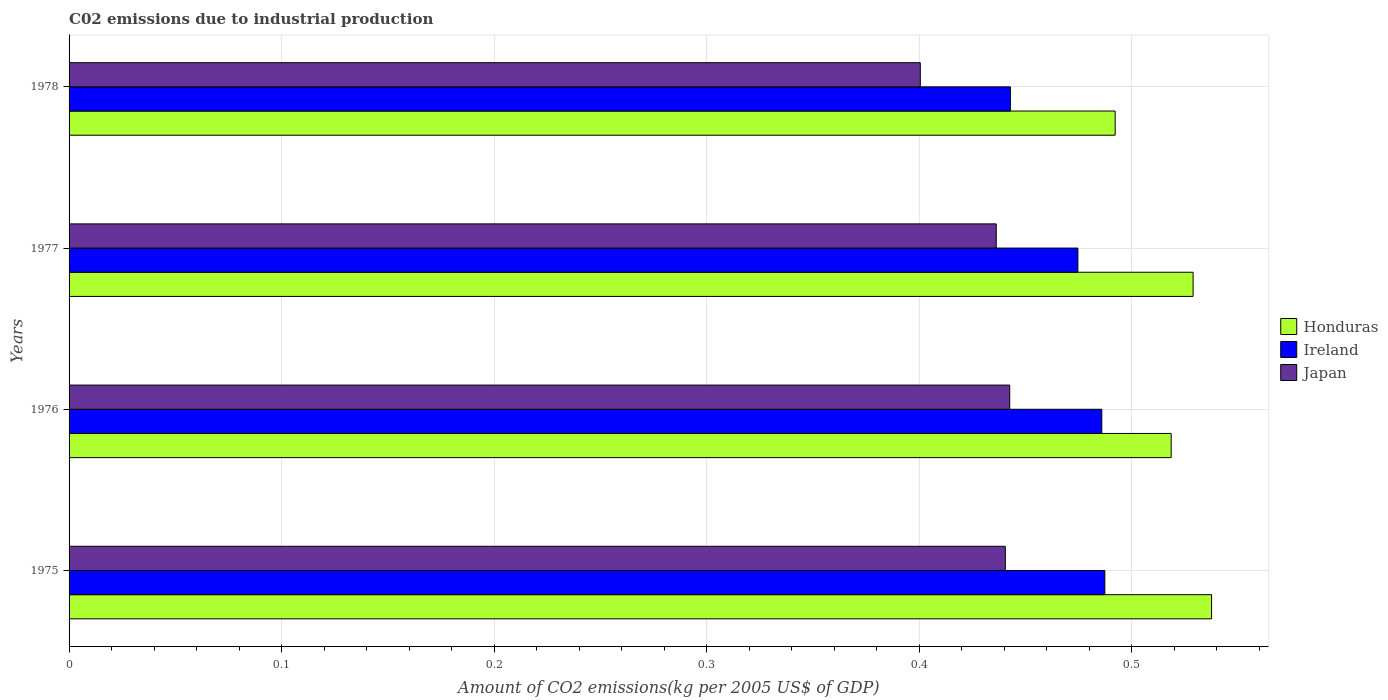Are the number of bars per tick equal to the number of legend labels?
Provide a short and direct response. Yes. How many bars are there on the 2nd tick from the bottom?
Offer a terse response. 3. What is the label of the 1st group of bars from the top?
Keep it short and to the point. 1978. What is the amount of CO2 emitted due to industrial production in Ireland in 1975?
Provide a short and direct response. 0.49. Across all years, what is the maximum amount of CO2 emitted due to industrial production in Japan?
Provide a succinct answer. 0.44. Across all years, what is the minimum amount of CO2 emitted due to industrial production in Japan?
Provide a succinct answer. 0.4. In which year was the amount of CO2 emitted due to industrial production in Honduras maximum?
Provide a short and direct response. 1975. In which year was the amount of CO2 emitted due to industrial production in Honduras minimum?
Provide a short and direct response. 1978. What is the total amount of CO2 emitted due to industrial production in Ireland in the graph?
Provide a succinct answer. 1.89. What is the difference between the amount of CO2 emitted due to industrial production in Honduras in 1977 and that in 1978?
Offer a very short reply. 0.04. What is the difference between the amount of CO2 emitted due to industrial production in Honduras in 1978 and the amount of CO2 emitted due to industrial production in Ireland in 1977?
Give a very brief answer. 0.02. What is the average amount of CO2 emitted due to industrial production in Japan per year?
Provide a succinct answer. 0.43. In the year 1976, what is the difference between the amount of CO2 emitted due to industrial production in Japan and amount of CO2 emitted due to industrial production in Ireland?
Make the answer very short. -0.04. In how many years, is the amount of CO2 emitted due to industrial production in Honduras greater than 0.16 kg?
Offer a very short reply. 4. What is the ratio of the amount of CO2 emitted due to industrial production in Ireland in 1976 to that in 1978?
Give a very brief answer. 1.1. Is the amount of CO2 emitted due to industrial production in Honduras in 1975 less than that in 1976?
Provide a short and direct response. No. Is the difference between the amount of CO2 emitted due to industrial production in Japan in 1975 and 1977 greater than the difference between the amount of CO2 emitted due to industrial production in Ireland in 1975 and 1977?
Provide a succinct answer. No. What is the difference between the highest and the second highest amount of CO2 emitted due to industrial production in Ireland?
Provide a short and direct response. 0. What is the difference between the highest and the lowest amount of CO2 emitted due to industrial production in Honduras?
Your response must be concise. 0.05. Is the sum of the amount of CO2 emitted due to industrial production in Honduras in 1976 and 1977 greater than the maximum amount of CO2 emitted due to industrial production in Ireland across all years?
Your response must be concise. Yes. What does the 2nd bar from the top in 1977 represents?
Provide a succinct answer. Ireland. How many bars are there?
Offer a very short reply. 12. Are all the bars in the graph horizontal?
Provide a short and direct response. Yes. How many years are there in the graph?
Your answer should be compact. 4. Are the values on the major ticks of X-axis written in scientific E-notation?
Provide a short and direct response. No. Does the graph contain any zero values?
Your answer should be compact. No. Does the graph contain grids?
Give a very brief answer. Yes. Where does the legend appear in the graph?
Offer a terse response. Center right. How many legend labels are there?
Make the answer very short. 3. What is the title of the graph?
Your response must be concise. C02 emissions due to industrial production. Does "Vietnam" appear as one of the legend labels in the graph?
Your answer should be compact. No. What is the label or title of the X-axis?
Your answer should be very brief. Amount of CO2 emissions(kg per 2005 US$ of GDP). What is the Amount of CO2 emissions(kg per 2005 US$ of GDP) of Honduras in 1975?
Keep it short and to the point. 0.54. What is the Amount of CO2 emissions(kg per 2005 US$ of GDP) of Ireland in 1975?
Provide a succinct answer. 0.49. What is the Amount of CO2 emissions(kg per 2005 US$ of GDP) in Japan in 1975?
Provide a succinct answer. 0.44. What is the Amount of CO2 emissions(kg per 2005 US$ of GDP) of Honduras in 1976?
Your answer should be compact. 0.52. What is the Amount of CO2 emissions(kg per 2005 US$ of GDP) in Ireland in 1976?
Your response must be concise. 0.49. What is the Amount of CO2 emissions(kg per 2005 US$ of GDP) of Japan in 1976?
Provide a succinct answer. 0.44. What is the Amount of CO2 emissions(kg per 2005 US$ of GDP) in Honduras in 1977?
Make the answer very short. 0.53. What is the Amount of CO2 emissions(kg per 2005 US$ of GDP) in Ireland in 1977?
Make the answer very short. 0.47. What is the Amount of CO2 emissions(kg per 2005 US$ of GDP) of Japan in 1977?
Make the answer very short. 0.44. What is the Amount of CO2 emissions(kg per 2005 US$ of GDP) of Honduras in 1978?
Provide a short and direct response. 0.49. What is the Amount of CO2 emissions(kg per 2005 US$ of GDP) of Ireland in 1978?
Your response must be concise. 0.44. What is the Amount of CO2 emissions(kg per 2005 US$ of GDP) in Japan in 1978?
Keep it short and to the point. 0.4. Across all years, what is the maximum Amount of CO2 emissions(kg per 2005 US$ of GDP) in Honduras?
Give a very brief answer. 0.54. Across all years, what is the maximum Amount of CO2 emissions(kg per 2005 US$ of GDP) of Ireland?
Your response must be concise. 0.49. Across all years, what is the maximum Amount of CO2 emissions(kg per 2005 US$ of GDP) in Japan?
Give a very brief answer. 0.44. Across all years, what is the minimum Amount of CO2 emissions(kg per 2005 US$ of GDP) of Honduras?
Ensure brevity in your answer.  0.49. Across all years, what is the minimum Amount of CO2 emissions(kg per 2005 US$ of GDP) in Ireland?
Your answer should be very brief. 0.44. Across all years, what is the minimum Amount of CO2 emissions(kg per 2005 US$ of GDP) of Japan?
Your answer should be very brief. 0.4. What is the total Amount of CO2 emissions(kg per 2005 US$ of GDP) in Honduras in the graph?
Ensure brevity in your answer.  2.08. What is the total Amount of CO2 emissions(kg per 2005 US$ of GDP) of Ireland in the graph?
Your answer should be very brief. 1.89. What is the total Amount of CO2 emissions(kg per 2005 US$ of GDP) in Japan in the graph?
Give a very brief answer. 1.72. What is the difference between the Amount of CO2 emissions(kg per 2005 US$ of GDP) of Honduras in 1975 and that in 1976?
Your answer should be compact. 0.02. What is the difference between the Amount of CO2 emissions(kg per 2005 US$ of GDP) in Ireland in 1975 and that in 1976?
Your answer should be compact. 0. What is the difference between the Amount of CO2 emissions(kg per 2005 US$ of GDP) of Japan in 1975 and that in 1976?
Provide a succinct answer. -0. What is the difference between the Amount of CO2 emissions(kg per 2005 US$ of GDP) of Honduras in 1975 and that in 1977?
Provide a succinct answer. 0.01. What is the difference between the Amount of CO2 emissions(kg per 2005 US$ of GDP) of Ireland in 1975 and that in 1977?
Provide a short and direct response. 0.01. What is the difference between the Amount of CO2 emissions(kg per 2005 US$ of GDP) in Japan in 1975 and that in 1977?
Your answer should be very brief. 0. What is the difference between the Amount of CO2 emissions(kg per 2005 US$ of GDP) of Honduras in 1975 and that in 1978?
Provide a short and direct response. 0.05. What is the difference between the Amount of CO2 emissions(kg per 2005 US$ of GDP) in Ireland in 1975 and that in 1978?
Offer a very short reply. 0.04. What is the difference between the Amount of CO2 emissions(kg per 2005 US$ of GDP) of Japan in 1975 and that in 1978?
Offer a very short reply. 0.04. What is the difference between the Amount of CO2 emissions(kg per 2005 US$ of GDP) in Honduras in 1976 and that in 1977?
Keep it short and to the point. -0.01. What is the difference between the Amount of CO2 emissions(kg per 2005 US$ of GDP) of Ireland in 1976 and that in 1977?
Offer a terse response. 0.01. What is the difference between the Amount of CO2 emissions(kg per 2005 US$ of GDP) of Japan in 1976 and that in 1977?
Provide a succinct answer. 0.01. What is the difference between the Amount of CO2 emissions(kg per 2005 US$ of GDP) in Honduras in 1976 and that in 1978?
Give a very brief answer. 0.03. What is the difference between the Amount of CO2 emissions(kg per 2005 US$ of GDP) of Ireland in 1976 and that in 1978?
Keep it short and to the point. 0.04. What is the difference between the Amount of CO2 emissions(kg per 2005 US$ of GDP) of Japan in 1976 and that in 1978?
Your response must be concise. 0.04. What is the difference between the Amount of CO2 emissions(kg per 2005 US$ of GDP) in Honduras in 1977 and that in 1978?
Provide a succinct answer. 0.04. What is the difference between the Amount of CO2 emissions(kg per 2005 US$ of GDP) in Ireland in 1977 and that in 1978?
Provide a short and direct response. 0.03. What is the difference between the Amount of CO2 emissions(kg per 2005 US$ of GDP) of Japan in 1977 and that in 1978?
Ensure brevity in your answer.  0.04. What is the difference between the Amount of CO2 emissions(kg per 2005 US$ of GDP) of Honduras in 1975 and the Amount of CO2 emissions(kg per 2005 US$ of GDP) of Ireland in 1976?
Give a very brief answer. 0.05. What is the difference between the Amount of CO2 emissions(kg per 2005 US$ of GDP) in Honduras in 1975 and the Amount of CO2 emissions(kg per 2005 US$ of GDP) in Japan in 1976?
Provide a short and direct response. 0.1. What is the difference between the Amount of CO2 emissions(kg per 2005 US$ of GDP) of Ireland in 1975 and the Amount of CO2 emissions(kg per 2005 US$ of GDP) of Japan in 1976?
Offer a very short reply. 0.04. What is the difference between the Amount of CO2 emissions(kg per 2005 US$ of GDP) in Honduras in 1975 and the Amount of CO2 emissions(kg per 2005 US$ of GDP) in Ireland in 1977?
Your answer should be very brief. 0.06. What is the difference between the Amount of CO2 emissions(kg per 2005 US$ of GDP) of Honduras in 1975 and the Amount of CO2 emissions(kg per 2005 US$ of GDP) of Japan in 1977?
Your answer should be compact. 0.1. What is the difference between the Amount of CO2 emissions(kg per 2005 US$ of GDP) in Ireland in 1975 and the Amount of CO2 emissions(kg per 2005 US$ of GDP) in Japan in 1977?
Offer a very short reply. 0.05. What is the difference between the Amount of CO2 emissions(kg per 2005 US$ of GDP) in Honduras in 1975 and the Amount of CO2 emissions(kg per 2005 US$ of GDP) in Ireland in 1978?
Offer a terse response. 0.09. What is the difference between the Amount of CO2 emissions(kg per 2005 US$ of GDP) of Honduras in 1975 and the Amount of CO2 emissions(kg per 2005 US$ of GDP) of Japan in 1978?
Provide a short and direct response. 0.14. What is the difference between the Amount of CO2 emissions(kg per 2005 US$ of GDP) of Ireland in 1975 and the Amount of CO2 emissions(kg per 2005 US$ of GDP) of Japan in 1978?
Offer a very short reply. 0.09. What is the difference between the Amount of CO2 emissions(kg per 2005 US$ of GDP) in Honduras in 1976 and the Amount of CO2 emissions(kg per 2005 US$ of GDP) in Ireland in 1977?
Offer a terse response. 0.04. What is the difference between the Amount of CO2 emissions(kg per 2005 US$ of GDP) of Honduras in 1976 and the Amount of CO2 emissions(kg per 2005 US$ of GDP) of Japan in 1977?
Make the answer very short. 0.08. What is the difference between the Amount of CO2 emissions(kg per 2005 US$ of GDP) of Ireland in 1976 and the Amount of CO2 emissions(kg per 2005 US$ of GDP) of Japan in 1977?
Your response must be concise. 0.05. What is the difference between the Amount of CO2 emissions(kg per 2005 US$ of GDP) of Honduras in 1976 and the Amount of CO2 emissions(kg per 2005 US$ of GDP) of Ireland in 1978?
Your answer should be compact. 0.08. What is the difference between the Amount of CO2 emissions(kg per 2005 US$ of GDP) in Honduras in 1976 and the Amount of CO2 emissions(kg per 2005 US$ of GDP) in Japan in 1978?
Give a very brief answer. 0.12. What is the difference between the Amount of CO2 emissions(kg per 2005 US$ of GDP) in Ireland in 1976 and the Amount of CO2 emissions(kg per 2005 US$ of GDP) in Japan in 1978?
Ensure brevity in your answer.  0.09. What is the difference between the Amount of CO2 emissions(kg per 2005 US$ of GDP) in Honduras in 1977 and the Amount of CO2 emissions(kg per 2005 US$ of GDP) in Ireland in 1978?
Provide a succinct answer. 0.09. What is the difference between the Amount of CO2 emissions(kg per 2005 US$ of GDP) in Honduras in 1977 and the Amount of CO2 emissions(kg per 2005 US$ of GDP) in Japan in 1978?
Your answer should be compact. 0.13. What is the difference between the Amount of CO2 emissions(kg per 2005 US$ of GDP) in Ireland in 1977 and the Amount of CO2 emissions(kg per 2005 US$ of GDP) in Japan in 1978?
Your answer should be compact. 0.07. What is the average Amount of CO2 emissions(kg per 2005 US$ of GDP) in Honduras per year?
Ensure brevity in your answer.  0.52. What is the average Amount of CO2 emissions(kg per 2005 US$ of GDP) in Ireland per year?
Keep it short and to the point. 0.47. What is the average Amount of CO2 emissions(kg per 2005 US$ of GDP) in Japan per year?
Offer a very short reply. 0.43. In the year 1975, what is the difference between the Amount of CO2 emissions(kg per 2005 US$ of GDP) of Honduras and Amount of CO2 emissions(kg per 2005 US$ of GDP) of Ireland?
Your answer should be compact. 0.05. In the year 1975, what is the difference between the Amount of CO2 emissions(kg per 2005 US$ of GDP) in Honduras and Amount of CO2 emissions(kg per 2005 US$ of GDP) in Japan?
Your answer should be very brief. 0.1. In the year 1975, what is the difference between the Amount of CO2 emissions(kg per 2005 US$ of GDP) of Ireland and Amount of CO2 emissions(kg per 2005 US$ of GDP) of Japan?
Your response must be concise. 0.05. In the year 1976, what is the difference between the Amount of CO2 emissions(kg per 2005 US$ of GDP) of Honduras and Amount of CO2 emissions(kg per 2005 US$ of GDP) of Ireland?
Your response must be concise. 0.03. In the year 1976, what is the difference between the Amount of CO2 emissions(kg per 2005 US$ of GDP) in Honduras and Amount of CO2 emissions(kg per 2005 US$ of GDP) in Japan?
Give a very brief answer. 0.08. In the year 1976, what is the difference between the Amount of CO2 emissions(kg per 2005 US$ of GDP) of Ireland and Amount of CO2 emissions(kg per 2005 US$ of GDP) of Japan?
Ensure brevity in your answer.  0.04. In the year 1977, what is the difference between the Amount of CO2 emissions(kg per 2005 US$ of GDP) in Honduras and Amount of CO2 emissions(kg per 2005 US$ of GDP) in Ireland?
Your response must be concise. 0.05. In the year 1977, what is the difference between the Amount of CO2 emissions(kg per 2005 US$ of GDP) of Honduras and Amount of CO2 emissions(kg per 2005 US$ of GDP) of Japan?
Your response must be concise. 0.09. In the year 1977, what is the difference between the Amount of CO2 emissions(kg per 2005 US$ of GDP) in Ireland and Amount of CO2 emissions(kg per 2005 US$ of GDP) in Japan?
Provide a short and direct response. 0.04. In the year 1978, what is the difference between the Amount of CO2 emissions(kg per 2005 US$ of GDP) of Honduras and Amount of CO2 emissions(kg per 2005 US$ of GDP) of Ireland?
Provide a short and direct response. 0.05. In the year 1978, what is the difference between the Amount of CO2 emissions(kg per 2005 US$ of GDP) in Honduras and Amount of CO2 emissions(kg per 2005 US$ of GDP) in Japan?
Your response must be concise. 0.09. In the year 1978, what is the difference between the Amount of CO2 emissions(kg per 2005 US$ of GDP) in Ireland and Amount of CO2 emissions(kg per 2005 US$ of GDP) in Japan?
Provide a succinct answer. 0.04. What is the ratio of the Amount of CO2 emissions(kg per 2005 US$ of GDP) in Honduras in 1975 to that in 1976?
Provide a succinct answer. 1.04. What is the ratio of the Amount of CO2 emissions(kg per 2005 US$ of GDP) of Ireland in 1975 to that in 1976?
Ensure brevity in your answer.  1. What is the ratio of the Amount of CO2 emissions(kg per 2005 US$ of GDP) in Japan in 1975 to that in 1976?
Ensure brevity in your answer.  1. What is the ratio of the Amount of CO2 emissions(kg per 2005 US$ of GDP) in Honduras in 1975 to that in 1977?
Offer a very short reply. 1.02. What is the ratio of the Amount of CO2 emissions(kg per 2005 US$ of GDP) of Ireland in 1975 to that in 1977?
Provide a short and direct response. 1.03. What is the ratio of the Amount of CO2 emissions(kg per 2005 US$ of GDP) of Japan in 1975 to that in 1977?
Offer a terse response. 1.01. What is the ratio of the Amount of CO2 emissions(kg per 2005 US$ of GDP) of Honduras in 1975 to that in 1978?
Provide a succinct answer. 1.09. What is the ratio of the Amount of CO2 emissions(kg per 2005 US$ of GDP) in Ireland in 1975 to that in 1978?
Give a very brief answer. 1.1. What is the ratio of the Amount of CO2 emissions(kg per 2005 US$ of GDP) of Japan in 1975 to that in 1978?
Your answer should be compact. 1.1. What is the ratio of the Amount of CO2 emissions(kg per 2005 US$ of GDP) in Honduras in 1976 to that in 1977?
Your answer should be very brief. 0.98. What is the ratio of the Amount of CO2 emissions(kg per 2005 US$ of GDP) of Ireland in 1976 to that in 1977?
Ensure brevity in your answer.  1.02. What is the ratio of the Amount of CO2 emissions(kg per 2005 US$ of GDP) in Japan in 1976 to that in 1977?
Give a very brief answer. 1.01. What is the ratio of the Amount of CO2 emissions(kg per 2005 US$ of GDP) in Honduras in 1976 to that in 1978?
Offer a very short reply. 1.05. What is the ratio of the Amount of CO2 emissions(kg per 2005 US$ of GDP) of Ireland in 1976 to that in 1978?
Your response must be concise. 1.1. What is the ratio of the Amount of CO2 emissions(kg per 2005 US$ of GDP) in Japan in 1976 to that in 1978?
Keep it short and to the point. 1.1. What is the ratio of the Amount of CO2 emissions(kg per 2005 US$ of GDP) in Honduras in 1977 to that in 1978?
Keep it short and to the point. 1.07. What is the ratio of the Amount of CO2 emissions(kg per 2005 US$ of GDP) in Ireland in 1977 to that in 1978?
Offer a terse response. 1.07. What is the ratio of the Amount of CO2 emissions(kg per 2005 US$ of GDP) in Japan in 1977 to that in 1978?
Your answer should be very brief. 1.09. What is the difference between the highest and the second highest Amount of CO2 emissions(kg per 2005 US$ of GDP) of Honduras?
Your answer should be very brief. 0.01. What is the difference between the highest and the second highest Amount of CO2 emissions(kg per 2005 US$ of GDP) of Ireland?
Your answer should be compact. 0. What is the difference between the highest and the second highest Amount of CO2 emissions(kg per 2005 US$ of GDP) in Japan?
Your answer should be very brief. 0. What is the difference between the highest and the lowest Amount of CO2 emissions(kg per 2005 US$ of GDP) of Honduras?
Your response must be concise. 0.05. What is the difference between the highest and the lowest Amount of CO2 emissions(kg per 2005 US$ of GDP) of Ireland?
Your answer should be very brief. 0.04. What is the difference between the highest and the lowest Amount of CO2 emissions(kg per 2005 US$ of GDP) of Japan?
Provide a succinct answer. 0.04. 